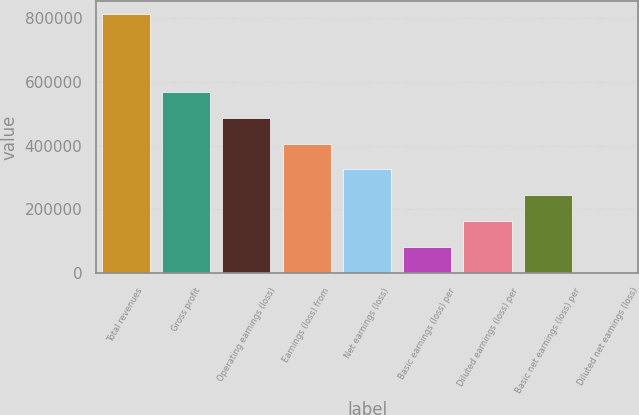Convert chart. <chart><loc_0><loc_0><loc_500><loc_500><bar_chart><fcel>Total revenues<fcel>Gross profit<fcel>Operating earnings (loss)<fcel>Earnings (loss) from<fcel>Net earnings (loss)<fcel>Basic earnings (loss) per<fcel>Diluted earnings (loss) per<fcel>Basic net earnings (loss) per<fcel>Diluted net earnings (loss)<nl><fcel>813568<fcel>569498<fcel>488141<fcel>406784<fcel>325427<fcel>81357.1<fcel>162714<fcel>244071<fcel>0.31<nl></chart> 